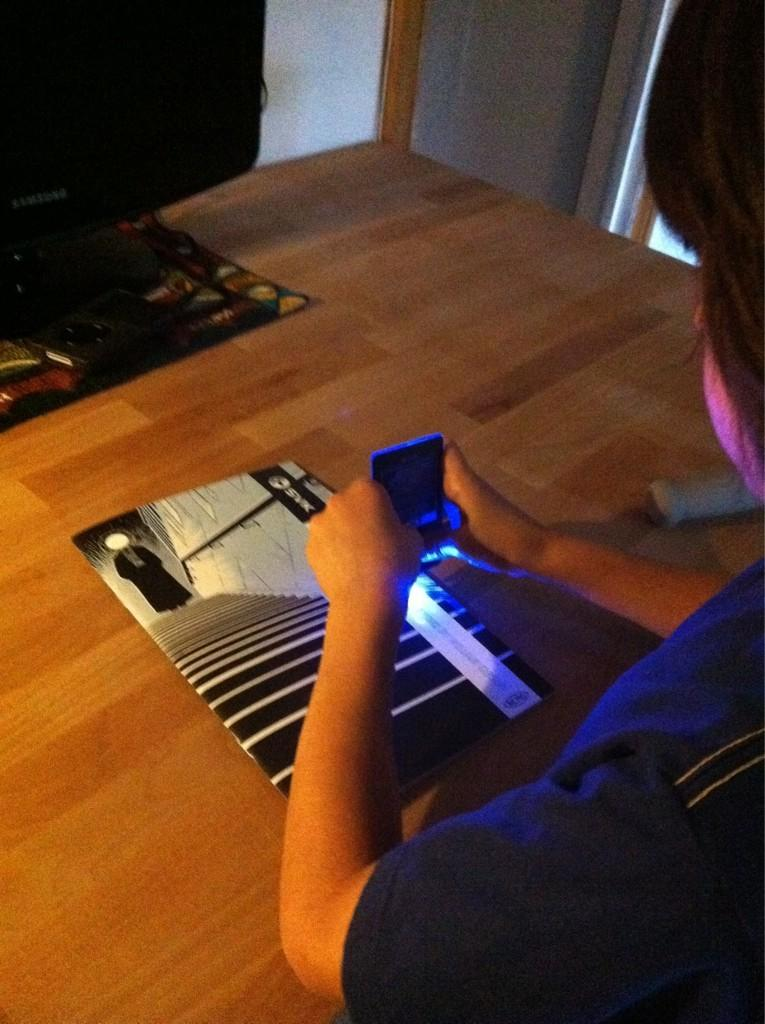What electronic device is present in the image? There is a monitor in the image. What type of reading material is visible in the image? There is a book in the image. What surface is present in the image for sitting or lying down? There is a mat in the image. What object is on the table in the image? There is an object on the table, but its specific nature is not mentioned in the facts. What is the person in the image holding? The person is holding a mobile in the image. What can be seen in the background of the image? There is a wall visible in the background of the image. How many spots can be seen on the cat in the image? There is no cat present in the image, so the number of spots cannot be determined. What is the baby doing in the image? There is no baby present in the image, so their actions cannot be described. 